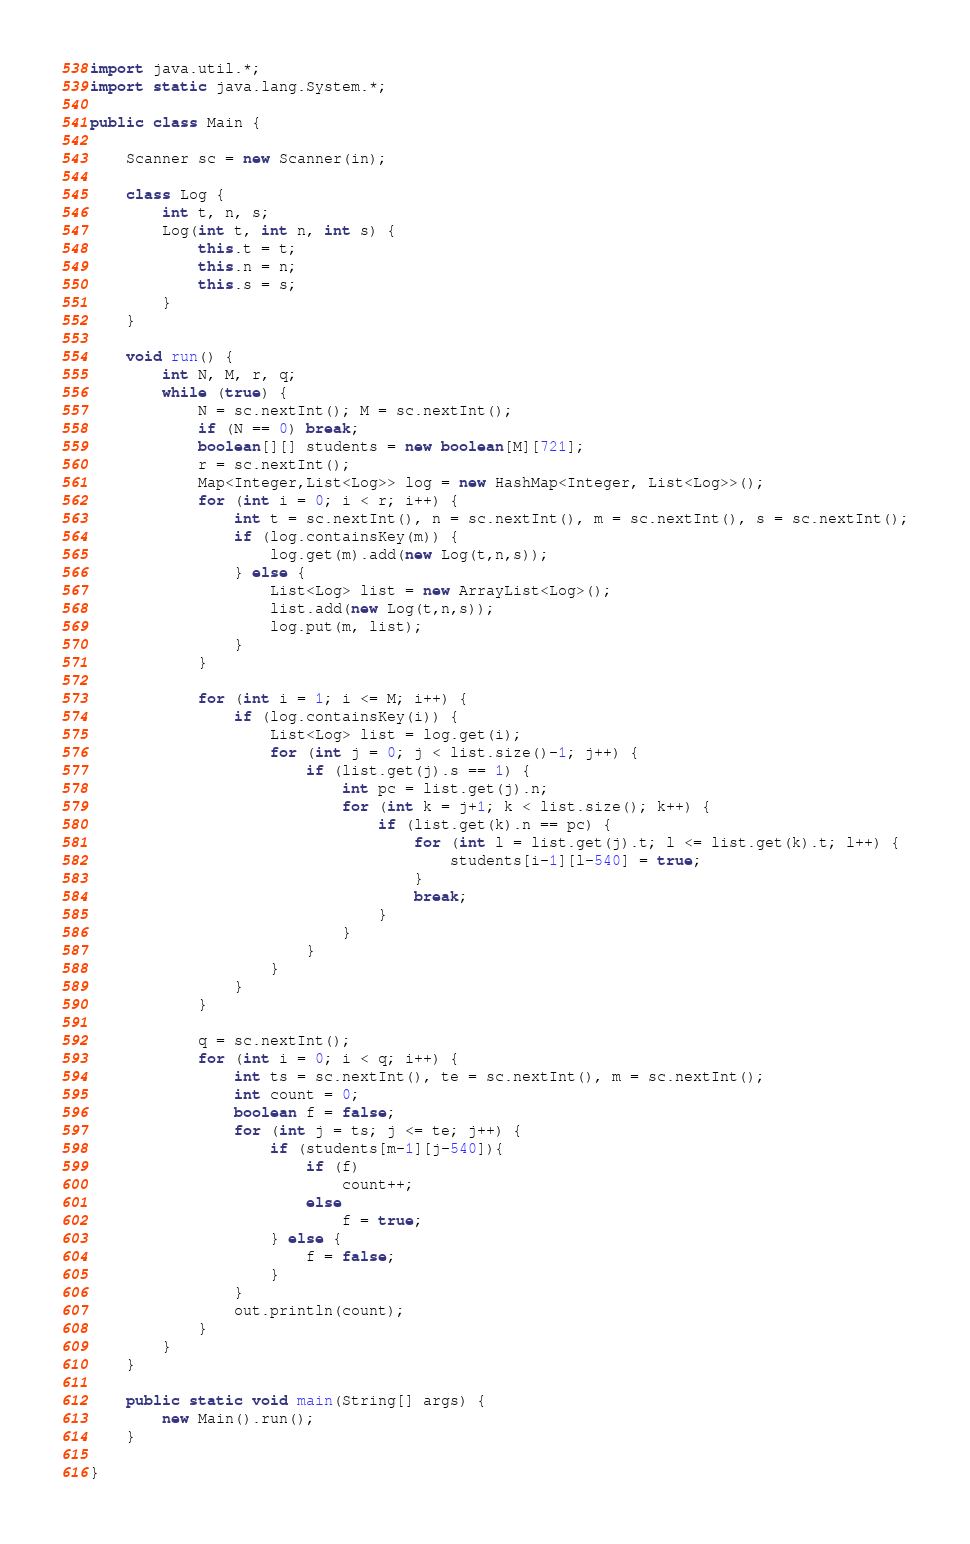Convert code to text. <code><loc_0><loc_0><loc_500><loc_500><_Java_>import java.util.*;
import static java.lang.System.*;

public class Main {

	Scanner sc = new Scanner(in);
	
	class Log {
		int t, n, s;
		Log(int t, int n, int s) {
			this.t = t;
			this.n = n;
			this.s = s;
		}
	}
	
	void run() {
		int N, M, r, q;
		while (true) {
			N = sc.nextInt(); M = sc.nextInt();
			if (N == 0) break;
			boolean[][] students = new boolean[M][721];
			r = sc.nextInt();
			Map<Integer,List<Log>> log = new HashMap<Integer, List<Log>>();
			for (int i = 0; i < r; i++) {
				int t = sc.nextInt(), n = sc.nextInt(), m = sc.nextInt(), s = sc.nextInt();
				if (log.containsKey(m)) {
					log.get(m).add(new Log(t,n,s));
				} else {
					List<Log> list = new ArrayList<Log>();
					list.add(new Log(t,n,s));
					log.put(m, list);
				}
			}
			
			for (int i = 1; i <= M; i++) {
				if (log.containsKey(i)) {
					List<Log> list = log.get(i);
					for (int j = 0; j < list.size()-1; j++) {
						if (list.get(j).s == 1) {
							int pc = list.get(j).n;
							for (int k = j+1; k < list.size(); k++) {
								if (list.get(k).n == pc) {
									for (int l = list.get(j).t; l <= list.get(k).t; l++) {
										students[i-1][l-540] = true;
									}
									break;
								}
							}
						}
					}
				}
			}
			
			q = sc.nextInt();
			for (int i = 0; i < q; i++) {
				int ts = sc.nextInt(), te = sc.nextInt(), m = sc.nextInt();
				int count = 0;
				boolean f = false;
				for (int j = ts; j <= te; j++) {
					if (students[m-1][j-540]){
						if (f)
							count++;
						else
							f = true;
					} else {
						f = false;
					}
				}
				out.println(count);
			}
		}
	}
	
	public static void main(String[] args) {
		new Main().run();
	}

}</code> 